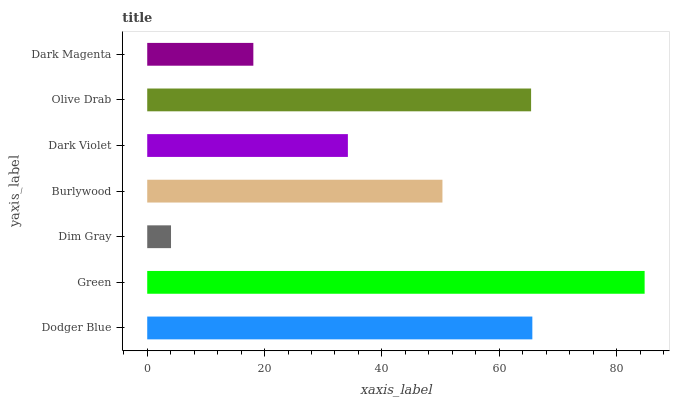Is Dim Gray the minimum?
Answer yes or no. Yes. Is Green the maximum?
Answer yes or no. Yes. Is Green the minimum?
Answer yes or no. No. Is Dim Gray the maximum?
Answer yes or no. No. Is Green greater than Dim Gray?
Answer yes or no. Yes. Is Dim Gray less than Green?
Answer yes or no. Yes. Is Dim Gray greater than Green?
Answer yes or no. No. Is Green less than Dim Gray?
Answer yes or no. No. Is Burlywood the high median?
Answer yes or no. Yes. Is Burlywood the low median?
Answer yes or no. Yes. Is Olive Drab the high median?
Answer yes or no. No. Is Dodger Blue the low median?
Answer yes or no. No. 